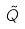<formula> <loc_0><loc_0><loc_500><loc_500>\tilde { Q }</formula> 